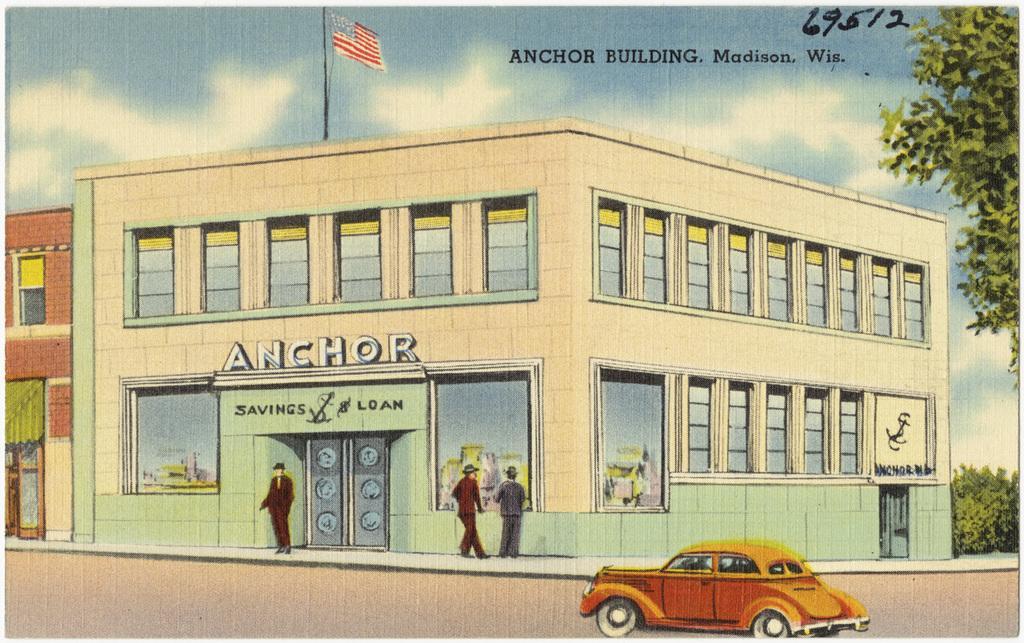In one or two sentences, can you explain what this image depicts? To the bottom of the image there is a road. To the right side of the road there is a car. Behind the car there is a building with walls, glass windows, pillars and doors. In front of the building there are few people standing on the footpath. To the left corner of the image there is a building with brick wall, window and door. Above the door there is a green tent. In the middle of the image to the top of the building there is a flag pole with the flag. To the top of the image there is a sky. To the right corner of the image there are trees. 